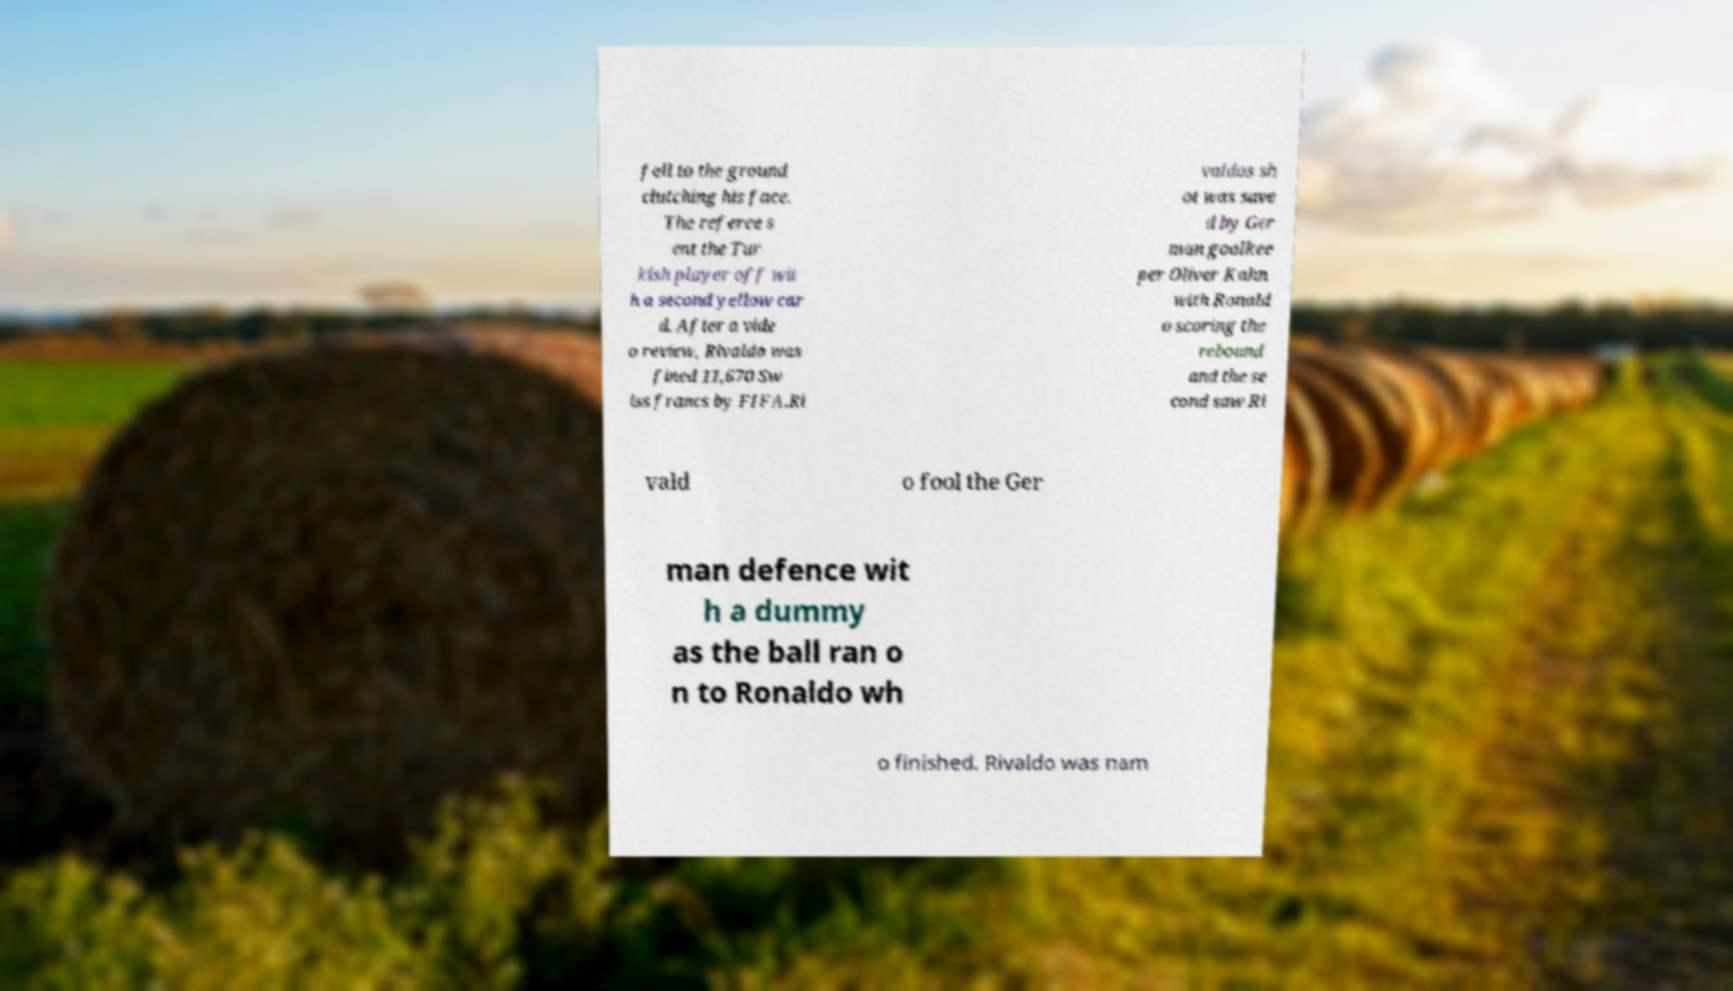I need the written content from this picture converted into text. Can you do that? fell to the ground clutching his face. The referee s ent the Tur kish player off wit h a second yellow car d. After a vide o review, Rivaldo was fined 11,670 Sw iss francs by FIFA.Ri valdos sh ot was save d by Ger man goalkee per Oliver Kahn with Ronald o scoring the rebound and the se cond saw Ri vald o fool the Ger man defence wit h a dummy as the ball ran o n to Ronaldo wh o finished. Rivaldo was nam 